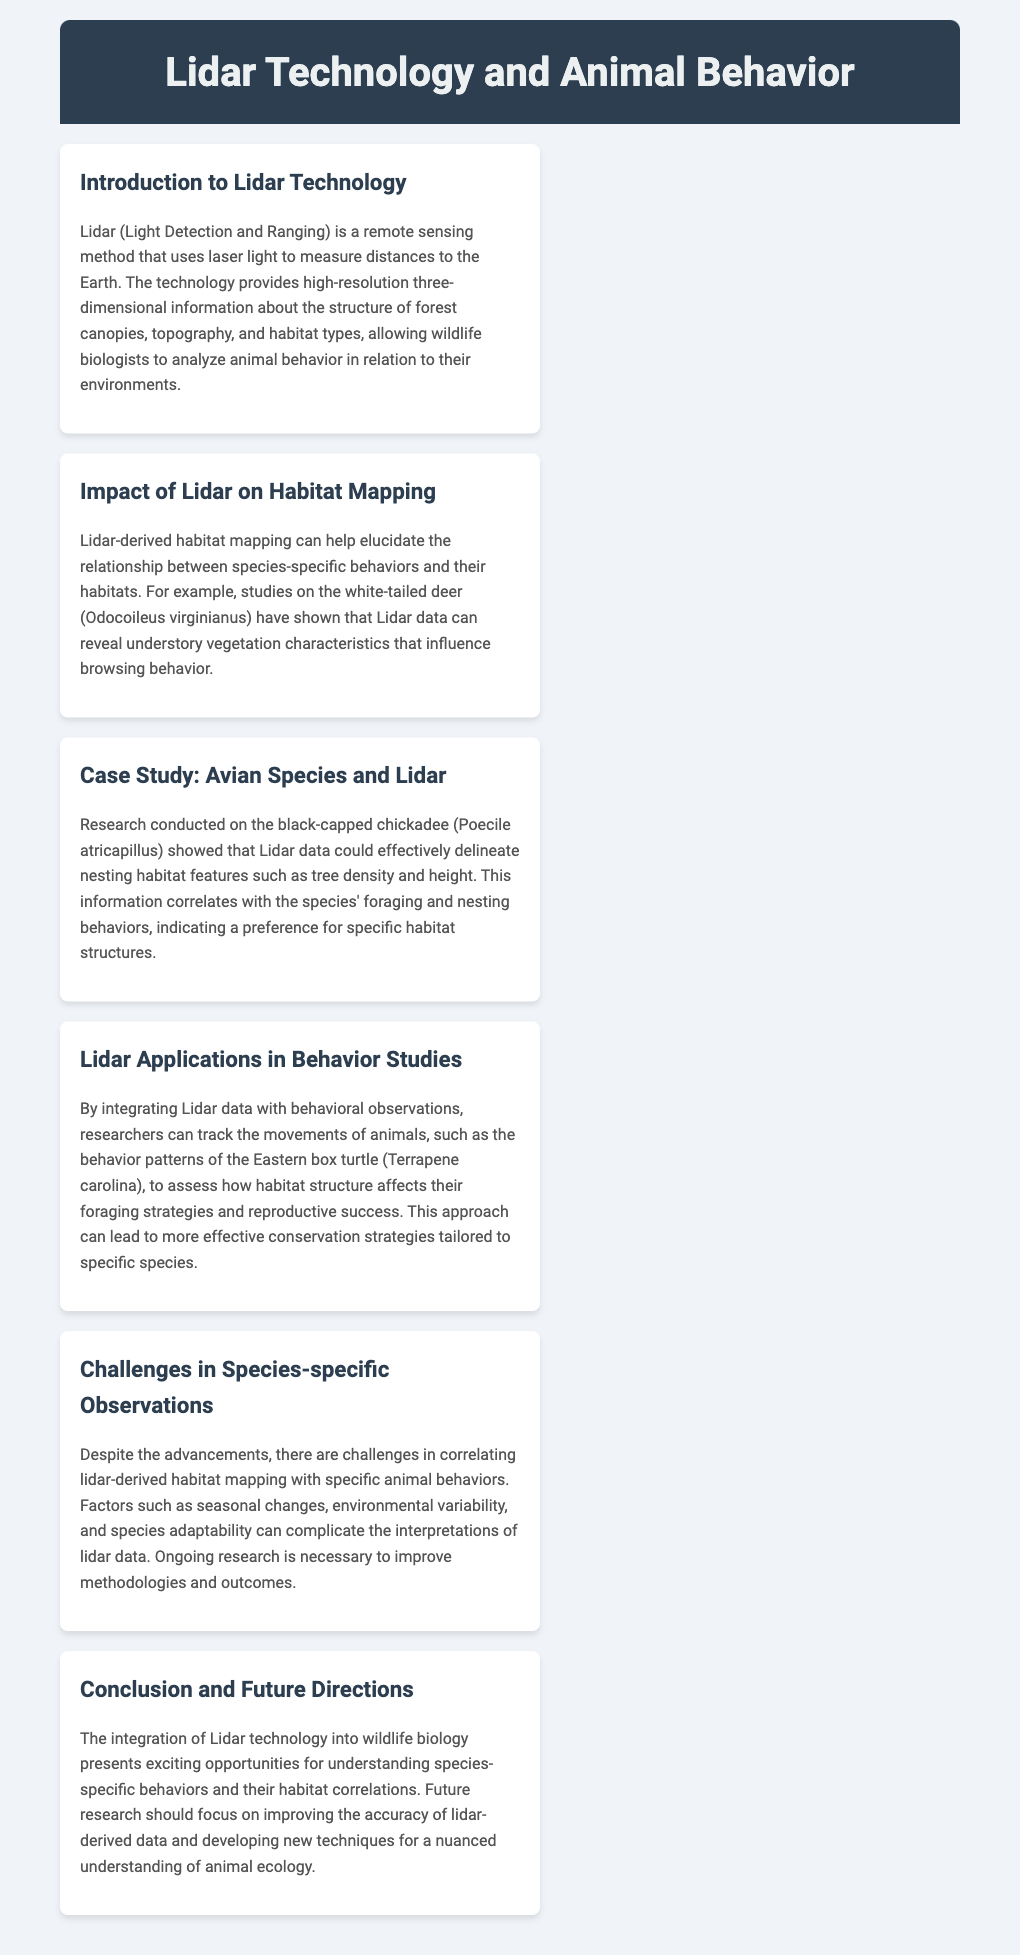What is Lidar an abbreviation for? Lidar stands for Light Detection and Ranging, as mentioned in the introduction section of the document.
Answer: Light Detection and Ranging Which species is highlighted in the case study for Lidar applications? The case study specifically mentions the black-capped chickadee and its habitat characteristics that are analyzed using Lidar data.
Answer: black-capped chickadee What is one characteristic of habitat that Lidar data revealed for white-tailed deer? The impact of Lidar on habitat mapping states that it can reveal understory vegetation characteristics affecting deer browsing behavior.
Answer: understory vegetation characteristics What behavioral patterns are assessed for Eastern box turtles using Lidar data? The Lidar applications section notes that researchers assess the foraging strategies and reproductive success of Eastern box turtles.
Answer: foraging strategies and reproductive success What year did the document's research conclude to future directions? The conclusion suggests that future research should focus on improving Lidar-derived data accuracy, but no specific year is mentioned for concluding the research.
Answer: N/A (no year mentioned) What is one challenge mentioned in species-specific observations? The challenges section discusses environmental variability as one of the complications in correlating Lidar-derived mapping with animal behaviors.
Answer: environmental variability 